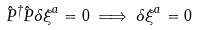<formula> <loc_0><loc_0><loc_500><loc_500>\hat { P } ^ { \dagger } \hat { P } { \delta \xi } ^ { a } = 0 \implies { \delta \xi } ^ { a } = 0</formula> 